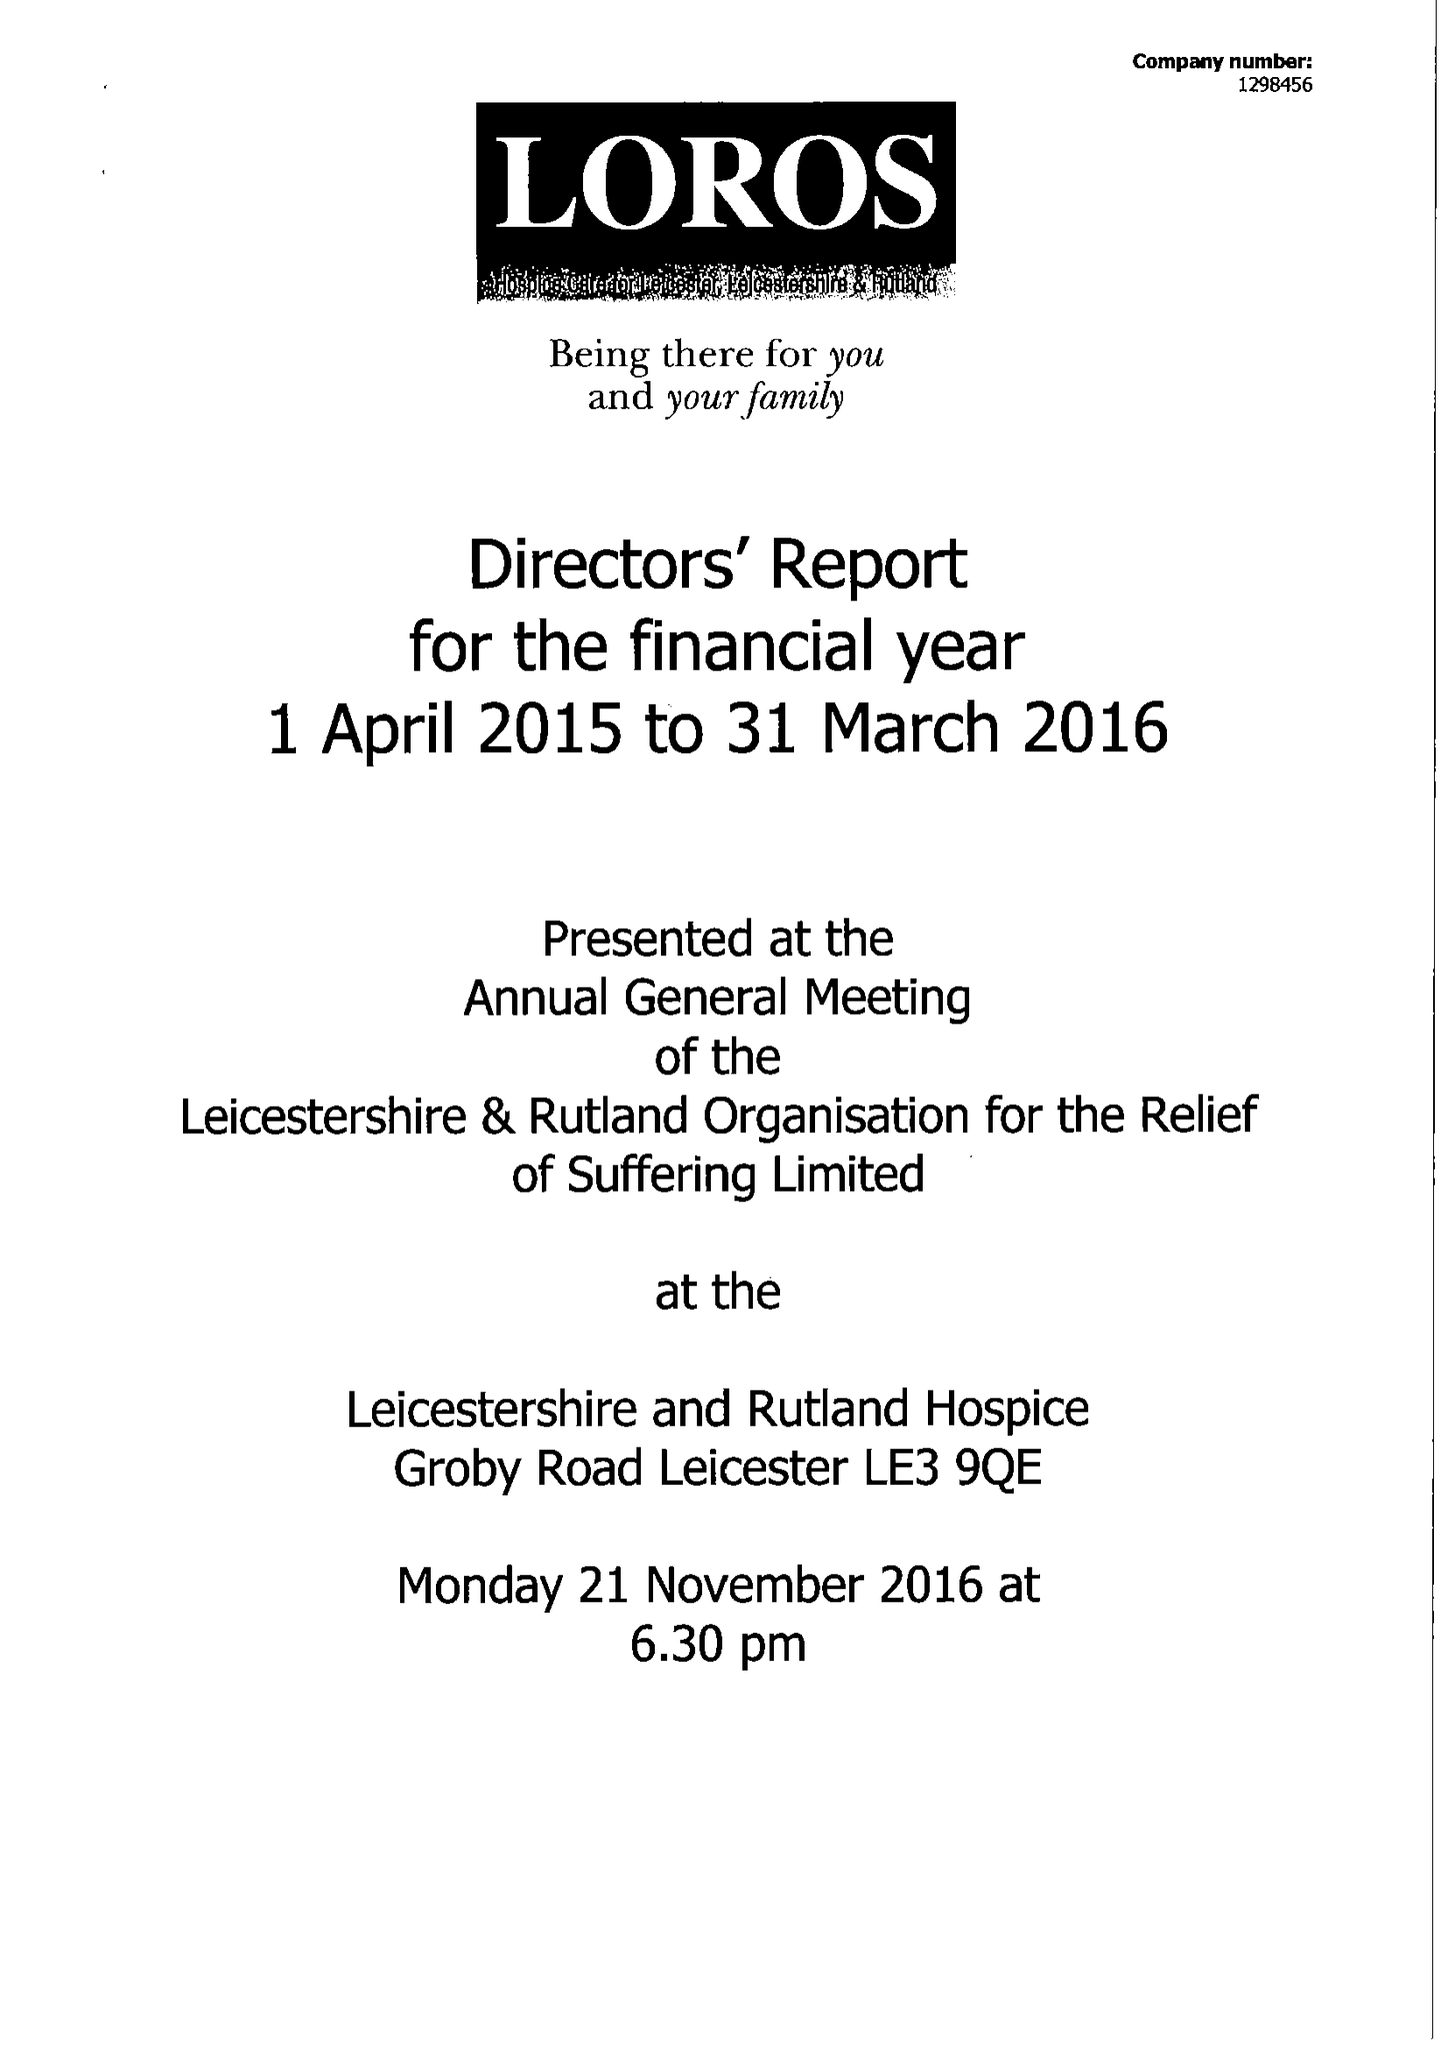What is the value for the charity_name?
Answer the question using a single word or phrase. Leicestershire and Rutland Organisation For The Relief Of Suffering Ltd. 